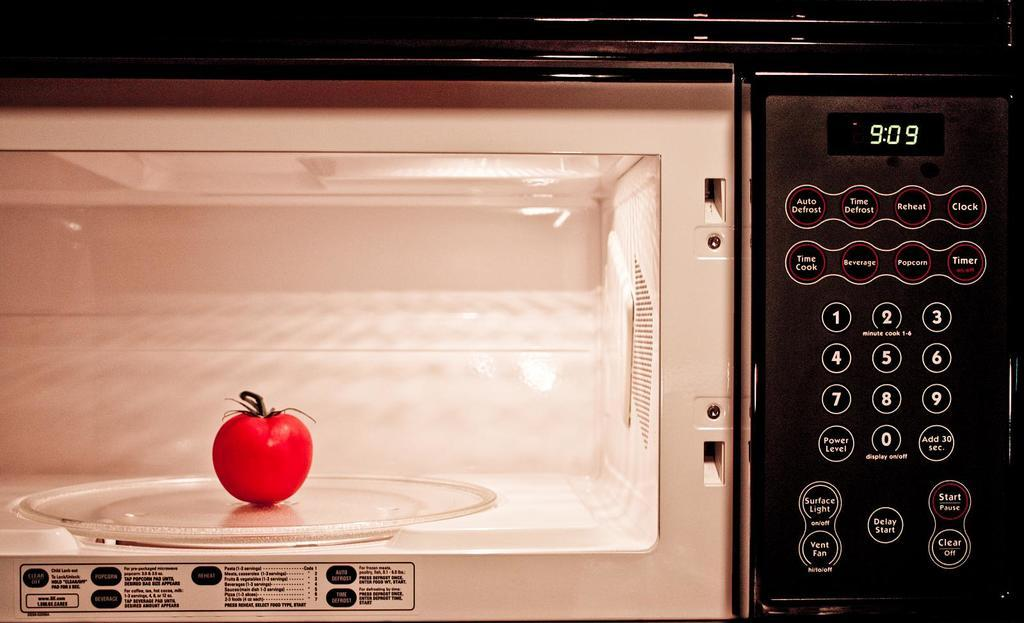<image>
Share a concise interpretation of the image provided. An apple in a microwave with 909 on the display. 